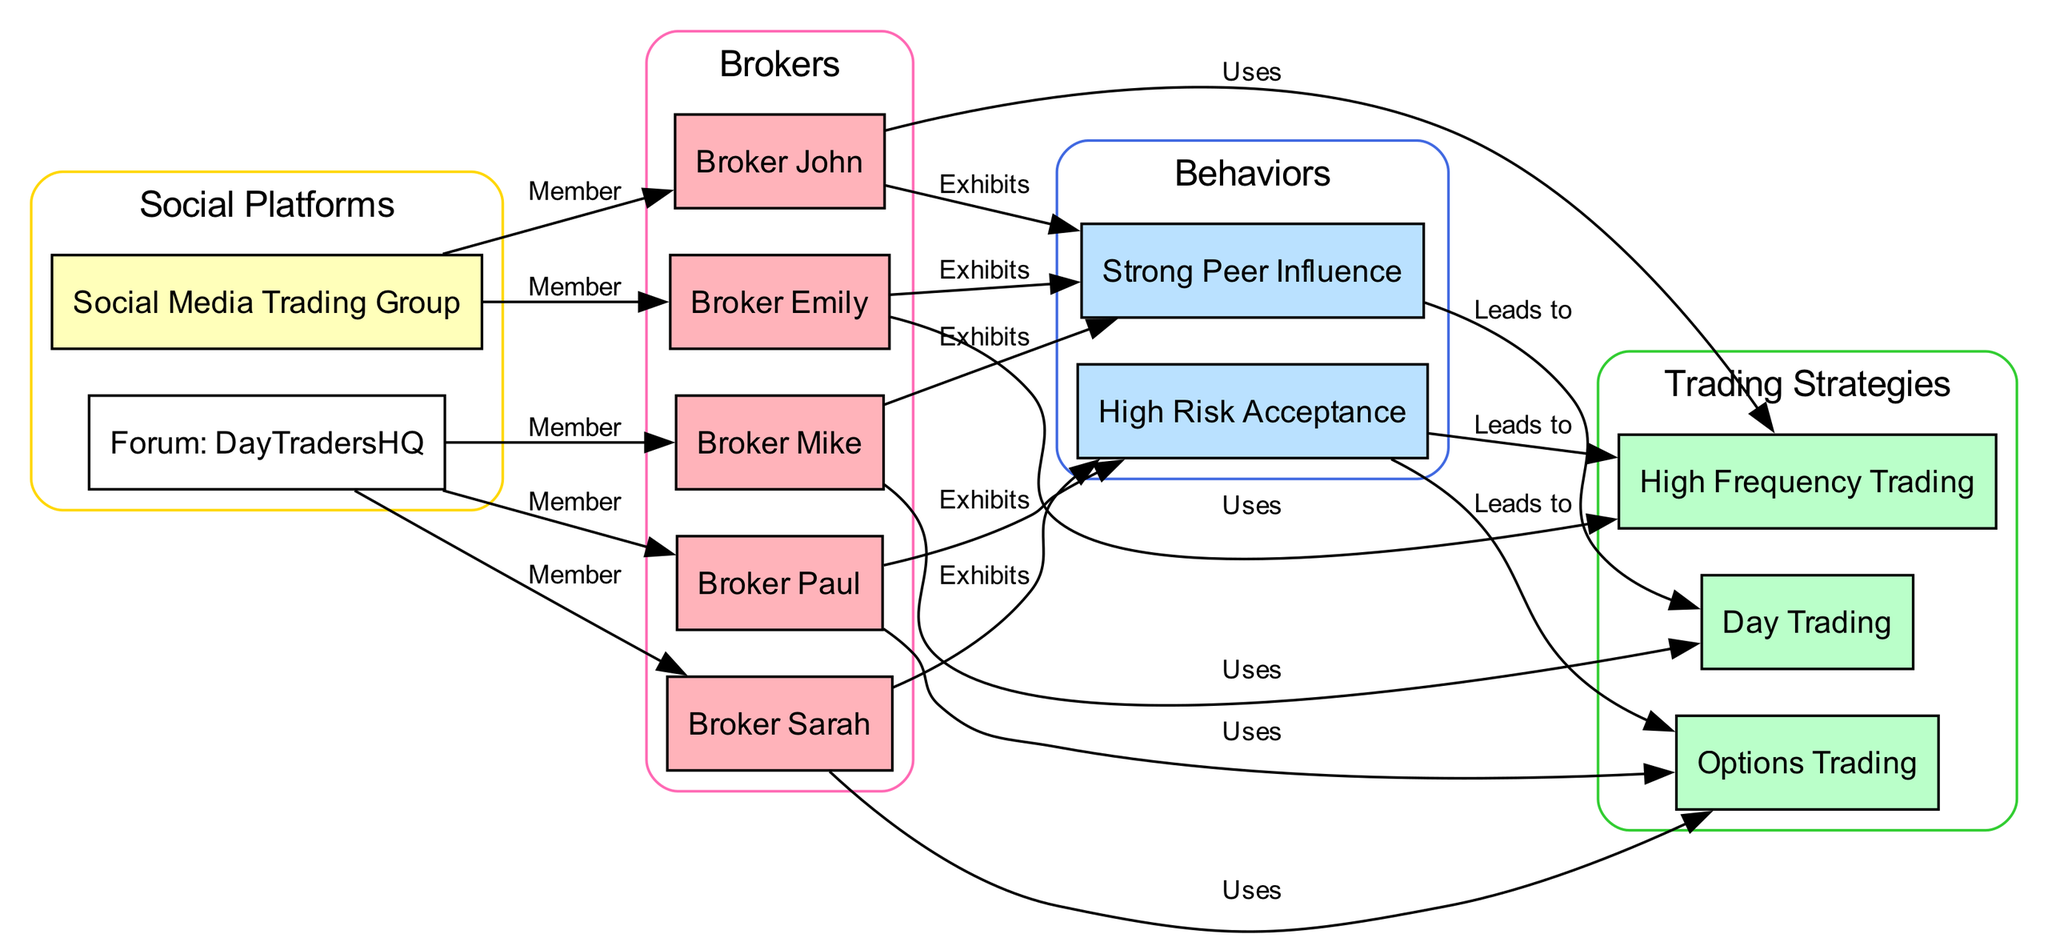What brokers are members of the Social Media Trading Group? To find the brokers in the Social Media Trading Group, I look at the edges connected to "Social_Media_Group" in the diagram. The edges indicate that Broker John and Broker Emily are members.
Answer: Broker John, Broker Emily Which strategies are associated with high risk acceptance? The diagram shows an edge from "Behavior_Risk_Acceptance" leading to both "Strategy_Options_Trading" and "Strategy_High_Frequency_Trading". This indicates that high risk acceptance influences both strategies.
Answer: Options Trading, High Frequency Trading How many brokers exhibit strong peer influence? I count the nodes that have edges leading to "Behavior_Peer_Influence_Strong". The brokers are Broker John, Broker Emily, and Broker Mike, making a total of three brokers.
Answer: 3 What is the relationship between Broker Mike and Day Trading? To determine the relationship, I follow the edges from Broker Mike. There is a node showing that Broker Mike uses the Day Trading strategy, indicating a direct connection.
Answer: Uses Which broker is associated with the Options Trading strategy? I look for an edge from a broker leading to "Strategy_Options_Trading". The diagram indicates that Broker Sarah and Broker Paul use this strategy.
Answer: Broker Sarah, Broker Paul Which behavior leads to Day Trading? The diagram indicates that the edge from "Behavior_Peer_Influence_Strong" leads to "Strategy_Day_Trading". This shows that strong peer influence is the behavior that results in Day Trading.
Answer: Strong Peer Influence How many edges connect the brokers to their respective strategies? I check the connections from each broker to their trading strategies. Broker John has one edge to high frequency trading, Broker Sarah to options trading, Broker Mike to day trading, Broker Emily to high frequency trading, and Broker Paul to options trading. There are a total of five edges.
Answer: 5 What social platforms do brokers belong to, according to the diagram? I look at the edges leading from social platforms. Brokers connected to the "Social_Media_Group" are Brokers John and Emily, while Brokers Sarah, Paul, and Mike belong to "Forum_DayTradersHQ". So combined, all brokers are accounted for in social platforms.
Answer: Social Media Trading Group, Forum: DayTradersHQ 